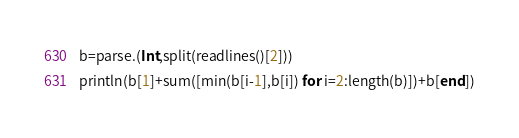<code> <loc_0><loc_0><loc_500><loc_500><_Julia_>b=parse.(Int,split(readlines()[2]))
println(b[1]+sum([min(b[i-1],b[i]) for i=2:length(b)])+b[end])</code> 